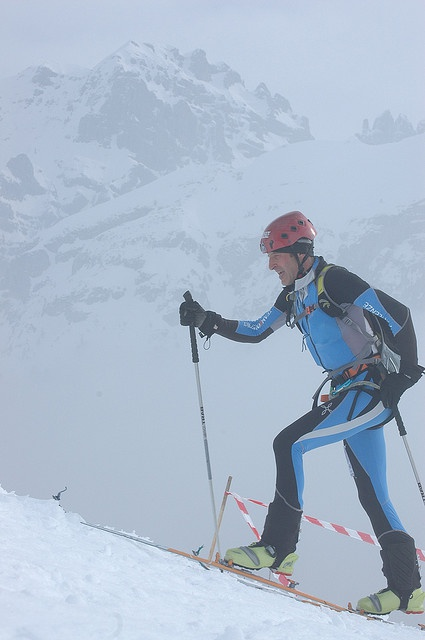Describe the objects in this image and their specific colors. I can see people in lavender, gray, and darkgray tones, backpack in lavender, gray, darkblue, and olive tones, and skis in lavender, darkgray, and tan tones in this image. 